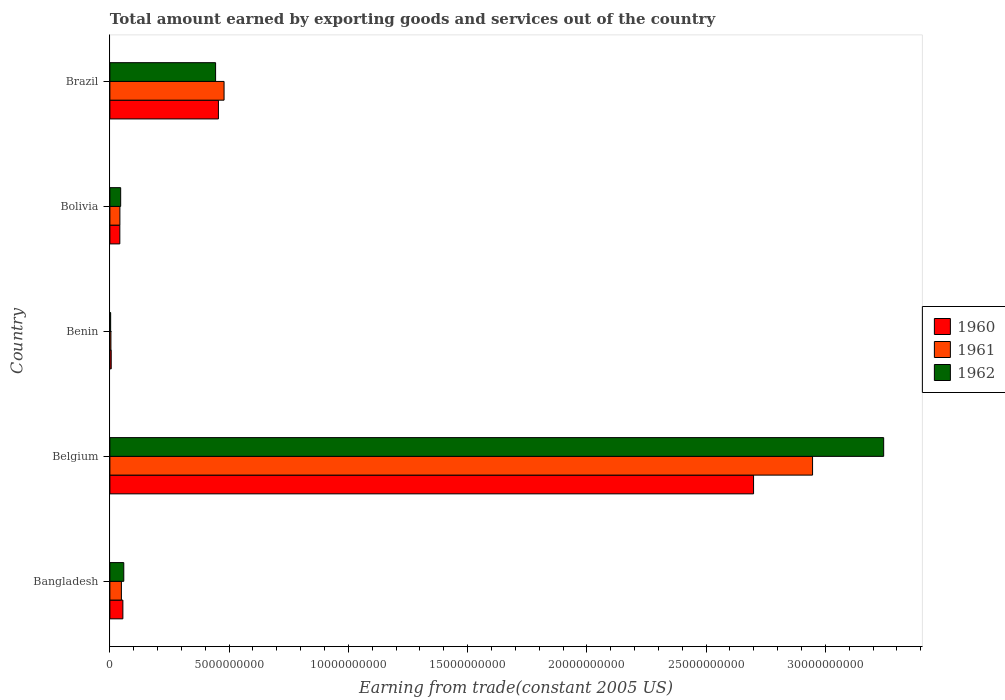How many groups of bars are there?
Provide a succinct answer. 5. Are the number of bars on each tick of the Y-axis equal?
Give a very brief answer. Yes. How many bars are there on the 3rd tick from the top?
Offer a terse response. 3. What is the total amount earned by exporting goods and services in 1962 in Benin?
Provide a short and direct response. 3.19e+07. Across all countries, what is the maximum total amount earned by exporting goods and services in 1960?
Your answer should be compact. 2.70e+1. Across all countries, what is the minimum total amount earned by exporting goods and services in 1960?
Your response must be concise. 5.55e+07. In which country was the total amount earned by exporting goods and services in 1961 minimum?
Your response must be concise. Benin. What is the total total amount earned by exporting goods and services in 1961 in the graph?
Your answer should be very brief. 3.52e+1. What is the difference between the total amount earned by exporting goods and services in 1961 in Bolivia and that in Brazil?
Your response must be concise. -4.37e+09. What is the difference between the total amount earned by exporting goods and services in 1962 in Bolivia and the total amount earned by exporting goods and services in 1960 in Belgium?
Make the answer very short. -2.65e+1. What is the average total amount earned by exporting goods and services in 1962 per country?
Provide a succinct answer. 7.59e+09. What is the difference between the total amount earned by exporting goods and services in 1962 and total amount earned by exporting goods and services in 1960 in Bangladesh?
Make the answer very short. 3.76e+07. In how many countries, is the total amount earned by exporting goods and services in 1962 greater than 17000000000 US$?
Provide a short and direct response. 1. What is the ratio of the total amount earned by exporting goods and services in 1961 in Benin to that in Brazil?
Make the answer very short. 0.01. Is the total amount earned by exporting goods and services in 1961 in Belgium less than that in Brazil?
Your response must be concise. No. Is the difference between the total amount earned by exporting goods and services in 1962 in Bangladesh and Belgium greater than the difference between the total amount earned by exporting goods and services in 1960 in Bangladesh and Belgium?
Provide a succinct answer. No. What is the difference between the highest and the second highest total amount earned by exporting goods and services in 1962?
Offer a very short reply. 2.80e+1. What is the difference between the highest and the lowest total amount earned by exporting goods and services in 1962?
Your answer should be compact. 3.24e+1. What does the 2nd bar from the top in Benin represents?
Keep it short and to the point. 1961. Is it the case that in every country, the sum of the total amount earned by exporting goods and services in 1960 and total amount earned by exporting goods and services in 1961 is greater than the total amount earned by exporting goods and services in 1962?
Keep it short and to the point. Yes. How many bars are there?
Your response must be concise. 15. Are all the bars in the graph horizontal?
Keep it short and to the point. Yes. Are the values on the major ticks of X-axis written in scientific E-notation?
Your answer should be very brief. No. Does the graph contain any zero values?
Ensure brevity in your answer.  No. Where does the legend appear in the graph?
Offer a terse response. Center right. How are the legend labels stacked?
Your answer should be compact. Vertical. What is the title of the graph?
Offer a very short reply. Total amount earned by exporting goods and services out of the country. Does "1960" appear as one of the legend labels in the graph?
Ensure brevity in your answer.  Yes. What is the label or title of the X-axis?
Keep it short and to the point. Earning from trade(constant 2005 US). What is the Earning from trade(constant 2005 US) of 1960 in Bangladesh?
Offer a very short reply. 5.45e+08. What is the Earning from trade(constant 2005 US) in 1961 in Bangladesh?
Offer a terse response. 4.82e+08. What is the Earning from trade(constant 2005 US) of 1962 in Bangladesh?
Your answer should be compact. 5.82e+08. What is the Earning from trade(constant 2005 US) in 1960 in Belgium?
Provide a short and direct response. 2.70e+1. What is the Earning from trade(constant 2005 US) of 1961 in Belgium?
Provide a short and direct response. 2.95e+1. What is the Earning from trade(constant 2005 US) of 1962 in Belgium?
Ensure brevity in your answer.  3.24e+1. What is the Earning from trade(constant 2005 US) of 1960 in Benin?
Your response must be concise. 5.55e+07. What is the Earning from trade(constant 2005 US) in 1961 in Benin?
Give a very brief answer. 4.35e+07. What is the Earning from trade(constant 2005 US) in 1962 in Benin?
Provide a succinct answer. 3.19e+07. What is the Earning from trade(constant 2005 US) of 1960 in Bolivia?
Your answer should be very brief. 4.17e+08. What is the Earning from trade(constant 2005 US) of 1961 in Bolivia?
Keep it short and to the point. 4.19e+08. What is the Earning from trade(constant 2005 US) of 1962 in Bolivia?
Give a very brief answer. 4.52e+08. What is the Earning from trade(constant 2005 US) in 1960 in Brazil?
Keep it short and to the point. 4.55e+09. What is the Earning from trade(constant 2005 US) of 1961 in Brazil?
Your answer should be very brief. 4.79e+09. What is the Earning from trade(constant 2005 US) in 1962 in Brazil?
Your answer should be compact. 4.43e+09. Across all countries, what is the maximum Earning from trade(constant 2005 US) of 1960?
Provide a succinct answer. 2.70e+1. Across all countries, what is the maximum Earning from trade(constant 2005 US) of 1961?
Provide a short and direct response. 2.95e+1. Across all countries, what is the maximum Earning from trade(constant 2005 US) in 1962?
Your response must be concise. 3.24e+1. Across all countries, what is the minimum Earning from trade(constant 2005 US) in 1960?
Offer a very short reply. 5.55e+07. Across all countries, what is the minimum Earning from trade(constant 2005 US) in 1961?
Provide a short and direct response. 4.35e+07. Across all countries, what is the minimum Earning from trade(constant 2005 US) of 1962?
Keep it short and to the point. 3.19e+07. What is the total Earning from trade(constant 2005 US) of 1960 in the graph?
Offer a terse response. 3.26e+1. What is the total Earning from trade(constant 2005 US) in 1961 in the graph?
Your answer should be compact. 3.52e+1. What is the total Earning from trade(constant 2005 US) of 1962 in the graph?
Keep it short and to the point. 3.79e+1. What is the difference between the Earning from trade(constant 2005 US) in 1960 in Bangladesh and that in Belgium?
Your response must be concise. -2.64e+1. What is the difference between the Earning from trade(constant 2005 US) in 1961 in Bangladesh and that in Belgium?
Your answer should be compact. -2.90e+1. What is the difference between the Earning from trade(constant 2005 US) of 1962 in Bangladesh and that in Belgium?
Ensure brevity in your answer.  -3.19e+1. What is the difference between the Earning from trade(constant 2005 US) in 1960 in Bangladesh and that in Benin?
Keep it short and to the point. 4.89e+08. What is the difference between the Earning from trade(constant 2005 US) of 1961 in Bangladesh and that in Benin?
Make the answer very short. 4.38e+08. What is the difference between the Earning from trade(constant 2005 US) in 1962 in Bangladesh and that in Benin?
Make the answer very short. 5.50e+08. What is the difference between the Earning from trade(constant 2005 US) in 1960 in Bangladesh and that in Bolivia?
Your response must be concise. 1.28e+08. What is the difference between the Earning from trade(constant 2005 US) of 1961 in Bangladesh and that in Bolivia?
Give a very brief answer. 6.29e+07. What is the difference between the Earning from trade(constant 2005 US) in 1962 in Bangladesh and that in Bolivia?
Provide a short and direct response. 1.30e+08. What is the difference between the Earning from trade(constant 2005 US) of 1960 in Bangladesh and that in Brazil?
Keep it short and to the point. -4.01e+09. What is the difference between the Earning from trade(constant 2005 US) in 1961 in Bangladesh and that in Brazil?
Give a very brief answer. -4.30e+09. What is the difference between the Earning from trade(constant 2005 US) of 1962 in Bangladesh and that in Brazil?
Your answer should be compact. -3.85e+09. What is the difference between the Earning from trade(constant 2005 US) in 1960 in Belgium and that in Benin?
Offer a terse response. 2.69e+1. What is the difference between the Earning from trade(constant 2005 US) in 1961 in Belgium and that in Benin?
Keep it short and to the point. 2.94e+1. What is the difference between the Earning from trade(constant 2005 US) in 1962 in Belgium and that in Benin?
Your answer should be compact. 3.24e+1. What is the difference between the Earning from trade(constant 2005 US) of 1960 in Belgium and that in Bolivia?
Make the answer very short. 2.66e+1. What is the difference between the Earning from trade(constant 2005 US) in 1961 in Belgium and that in Bolivia?
Provide a short and direct response. 2.90e+1. What is the difference between the Earning from trade(constant 2005 US) of 1962 in Belgium and that in Bolivia?
Give a very brief answer. 3.20e+1. What is the difference between the Earning from trade(constant 2005 US) of 1960 in Belgium and that in Brazil?
Offer a terse response. 2.24e+1. What is the difference between the Earning from trade(constant 2005 US) in 1961 in Belgium and that in Brazil?
Your response must be concise. 2.47e+1. What is the difference between the Earning from trade(constant 2005 US) of 1962 in Belgium and that in Brazil?
Keep it short and to the point. 2.80e+1. What is the difference between the Earning from trade(constant 2005 US) in 1960 in Benin and that in Bolivia?
Your response must be concise. -3.61e+08. What is the difference between the Earning from trade(constant 2005 US) of 1961 in Benin and that in Bolivia?
Offer a very short reply. -3.76e+08. What is the difference between the Earning from trade(constant 2005 US) in 1962 in Benin and that in Bolivia?
Provide a short and direct response. -4.20e+08. What is the difference between the Earning from trade(constant 2005 US) of 1960 in Benin and that in Brazil?
Ensure brevity in your answer.  -4.50e+09. What is the difference between the Earning from trade(constant 2005 US) in 1961 in Benin and that in Brazil?
Make the answer very short. -4.74e+09. What is the difference between the Earning from trade(constant 2005 US) of 1962 in Benin and that in Brazil?
Offer a very short reply. -4.40e+09. What is the difference between the Earning from trade(constant 2005 US) of 1960 in Bolivia and that in Brazil?
Make the answer very short. -4.13e+09. What is the difference between the Earning from trade(constant 2005 US) of 1961 in Bolivia and that in Brazil?
Your response must be concise. -4.37e+09. What is the difference between the Earning from trade(constant 2005 US) in 1962 in Bolivia and that in Brazil?
Your answer should be compact. -3.98e+09. What is the difference between the Earning from trade(constant 2005 US) in 1960 in Bangladesh and the Earning from trade(constant 2005 US) in 1961 in Belgium?
Give a very brief answer. -2.89e+1. What is the difference between the Earning from trade(constant 2005 US) in 1960 in Bangladesh and the Earning from trade(constant 2005 US) in 1962 in Belgium?
Provide a short and direct response. -3.19e+1. What is the difference between the Earning from trade(constant 2005 US) in 1961 in Bangladesh and the Earning from trade(constant 2005 US) in 1962 in Belgium?
Your answer should be compact. -3.20e+1. What is the difference between the Earning from trade(constant 2005 US) in 1960 in Bangladesh and the Earning from trade(constant 2005 US) in 1961 in Benin?
Your answer should be very brief. 5.01e+08. What is the difference between the Earning from trade(constant 2005 US) in 1960 in Bangladesh and the Earning from trade(constant 2005 US) in 1962 in Benin?
Offer a very short reply. 5.13e+08. What is the difference between the Earning from trade(constant 2005 US) of 1961 in Bangladesh and the Earning from trade(constant 2005 US) of 1962 in Benin?
Give a very brief answer. 4.50e+08. What is the difference between the Earning from trade(constant 2005 US) in 1960 in Bangladesh and the Earning from trade(constant 2005 US) in 1961 in Bolivia?
Ensure brevity in your answer.  1.26e+08. What is the difference between the Earning from trade(constant 2005 US) of 1960 in Bangladesh and the Earning from trade(constant 2005 US) of 1962 in Bolivia?
Provide a succinct answer. 9.25e+07. What is the difference between the Earning from trade(constant 2005 US) in 1961 in Bangladesh and the Earning from trade(constant 2005 US) in 1962 in Bolivia?
Ensure brevity in your answer.  2.98e+07. What is the difference between the Earning from trade(constant 2005 US) of 1960 in Bangladesh and the Earning from trade(constant 2005 US) of 1961 in Brazil?
Your answer should be very brief. -4.24e+09. What is the difference between the Earning from trade(constant 2005 US) of 1960 in Bangladesh and the Earning from trade(constant 2005 US) of 1962 in Brazil?
Your answer should be very brief. -3.89e+09. What is the difference between the Earning from trade(constant 2005 US) of 1961 in Bangladesh and the Earning from trade(constant 2005 US) of 1962 in Brazil?
Your answer should be very brief. -3.95e+09. What is the difference between the Earning from trade(constant 2005 US) in 1960 in Belgium and the Earning from trade(constant 2005 US) in 1961 in Benin?
Give a very brief answer. 2.69e+1. What is the difference between the Earning from trade(constant 2005 US) in 1960 in Belgium and the Earning from trade(constant 2005 US) in 1962 in Benin?
Provide a succinct answer. 2.70e+1. What is the difference between the Earning from trade(constant 2005 US) of 1961 in Belgium and the Earning from trade(constant 2005 US) of 1962 in Benin?
Your response must be concise. 2.94e+1. What is the difference between the Earning from trade(constant 2005 US) in 1960 in Belgium and the Earning from trade(constant 2005 US) in 1961 in Bolivia?
Ensure brevity in your answer.  2.66e+1. What is the difference between the Earning from trade(constant 2005 US) in 1960 in Belgium and the Earning from trade(constant 2005 US) in 1962 in Bolivia?
Your answer should be compact. 2.65e+1. What is the difference between the Earning from trade(constant 2005 US) in 1961 in Belgium and the Earning from trade(constant 2005 US) in 1962 in Bolivia?
Keep it short and to the point. 2.90e+1. What is the difference between the Earning from trade(constant 2005 US) of 1960 in Belgium and the Earning from trade(constant 2005 US) of 1961 in Brazil?
Offer a very short reply. 2.22e+1. What is the difference between the Earning from trade(constant 2005 US) of 1960 in Belgium and the Earning from trade(constant 2005 US) of 1962 in Brazil?
Provide a succinct answer. 2.26e+1. What is the difference between the Earning from trade(constant 2005 US) of 1961 in Belgium and the Earning from trade(constant 2005 US) of 1962 in Brazil?
Your answer should be very brief. 2.50e+1. What is the difference between the Earning from trade(constant 2005 US) in 1960 in Benin and the Earning from trade(constant 2005 US) in 1961 in Bolivia?
Give a very brief answer. -3.64e+08. What is the difference between the Earning from trade(constant 2005 US) in 1960 in Benin and the Earning from trade(constant 2005 US) in 1962 in Bolivia?
Keep it short and to the point. -3.97e+08. What is the difference between the Earning from trade(constant 2005 US) in 1961 in Benin and the Earning from trade(constant 2005 US) in 1962 in Bolivia?
Ensure brevity in your answer.  -4.09e+08. What is the difference between the Earning from trade(constant 2005 US) of 1960 in Benin and the Earning from trade(constant 2005 US) of 1961 in Brazil?
Keep it short and to the point. -4.73e+09. What is the difference between the Earning from trade(constant 2005 US) of 1960 in Benin and the Earning from trade(constant 2005 US) of 1962 in Brazil?
Keep it short and to the point. -4.38e+09. What is the difference between the Earning from trade(constant 2005 US) of 1961 in Benin and the Earning from trade(constant 2005 US) of 1962 in Brazil?
Keep it short and to the point. -4.39e+09. What is the difference between the Earning from trade(constant 2005 US) of 1960 in Bolivia and the Earning from trade(constant 2005 US) of 1961 in Brazil?
Give a very brief answer. -4.37e+09. What is the difference between the Earning from trade(constant 2005 US) in 1960 in Bolivia and the Earning from trade(constant 2005 US) in 1962 in Brazil?
Your answer should be compact. -4.02e+09. What is the difference between the Earning from trade(constant 2005 US) of 1961 in Bolivia and the Earning from trade(constant 2005 US) of 1962 in Brazil?
Provide a short and direct response. -4.01e+09. What is the average Earning from trade(constant 2005 US) in 1960 per country?
Offer a terse response. 6.51e+09. What is the average Earning from trade(constant 2005 US) in 1961 per country?
Ensure brevity in your answer.  7.04e+09. What is the average Earning from trade(constant 2005 US) in 1962 per country?
Give a very brief answer. 7.59e+09. What is the difference between the Earning from trade(constant 2005 US) of 1960 and Earning from trade(constant 2005 US) of 1961 in Bangladesh?
Your response must be concise. 6.26e+07. What is the difference between the Earning from trade(constant 2005 US) of 1960 and Earning from trade(constant 2005 US) of 1962 in Bangladesh?
Your answer should be very brief. -3.76e+07. What is the difference between the Earning from trade(constant 2005 US) of 1961 and Earning from trade(constant 2005 US) of 1962 in Bangladesh?
Keep it short and to the point. -1.00e+08. What is the difference between the Earning from trade(constant 2005 US) of 1960 and Earning from trade(constant 2005 US) of 1961 in Belgium?
Your answer should be very brief. -2.47e+09. What is the difference between the Earning from trade(constant 2005 US) of 1960 and Earning from trade(constant 2005 US) of 1962 in Belgium?
Provide a succinct answer. -5.46e+09. What is the difference between the Earning from trade(constant 2005 US) of 1961 and Earning from trade(constant 2005 US) of 1962 in Belgium?
Your response must be concise. -2.98e+09. What is the difference between the Earning from trade(constant 2005 US) in 1960 and Earning from trade(constant 2005 US) in 1961 in Benin?
Ensure brevity in your answer.  1.20e+07. What is the difference between the Earning from trade(constant 2005 US) of 1960 and Earning from trade(constant 2005 US) of 1962 in Benin?
Provide a succinct answer. 2.36e+07. What is the difference between the Earning from trade(constant 2005 US) of 1961 and Earning from trade(constant 2005 US) of 1962 in Benin?
Offer a terse response. 1.15e+07. What is the difference between the Earning from trade(constant 2005 US) of 1960 and Earning from trade(constant 2005 US) of 1961 in Bolivia?
Your answer should be compact. -2.45e+06. What is the difference between the Earning from trade(constant 2005 US) of 1960 and Earning from trade(constant 2005 US) of 1962 in Bolivia?
Your response must be concise. -3.55e+07. What is the difference between the Earning from trade(constant 2005 US) of 1961 and Earning from trade(constant 2005 US) of 1962 in Bolivia?
Give a very brief answer. -3.30e+07. What is the difference between the Earning from trade(constant 2005 US) in 1960 and Earning from trade(constant 2005 US) in 1961 in Brazil?
Your answer should be very brief. -2.36e+08. What is the difference between the Earning from trade(constant 2005 US) of 1960 and Earning from trade(constant 2005 US) of 1962 in Brazil?
Your answer should be very brief. 1.18e+08. What is the difference between the Earning from trade(constant 2005 US) of 1961 and Earning from trade(constant 2005 US) of 1962 in Brazil?
Make the answer very short. 3.55e+08. What is the ratio of the Earning from trade(constant 2005 US) of 1960 in Bangladesh to that in Belgium?
Your answer should be compact. 0.02. What is the ratio of the Earning from trade(constant 2005 US) in 1961 in Bangladesh to that in Belgium?
Offer a very short reply. 0.02. What is the ratio of the Earning from trade(constant 2005 US) in 1962 in Bangladesh to that in Belgium?
Your answer should be compact. 0.02. What is the ratio of the Earning from trade(constant 2005 US) in 1960 in Bangladesh to that in Benin?
Make the answer very short. 9.81. What is the ratio of the Earning from trade(constant 2005 US) of 1961 in Bangladesh to that in Benin?
Offer a very short reply. 11.09. What is the ratio of the Earning from trade(constant 2005 US) in 1962 in Bangladesh to that in Benin?
Your answer should be compact. 18.22. What is the ratio of the Earning from trade(constant 2005 US) of 1960 in Bangladesh to that in Bolivia?
Ensure brevity in your answer.  1.31. What is the ratio of the Earning from trade(constant 2005 US) of 1961 in Bangladesh to that in Bolivia?
Ensure brevity in your answer.  1.15. What is the ratio of the Earning from trade(constant 2005 US) of 1962 in Bangladesh to that in Bolivia?
Offer a terse response. 1.29. What is the ratio of the Earning from trade(constant 2005 US) of 1960 in Bangladesh to that in Brazil?
Offer a very short reply. 0.12. What is the ratio of the Earning from trade(constant 2005 US) in 1961 in Bangladesh to that in Brazil?
Provide a succinct answer. 0.1. What is the ratio of the Earning from trade(constant 2005 US) of 1962 in Bangladesh to that in Brazil?
Make the answer very short. 0.13. What is the ratio of the Earning from trade(constant 2005 US) in 1960 in Belgium to that in Benin?
Keep it short and to the point. 486.17. What is the ratio of the Earning from trade(constant 2005 US) of 1961 in Belgium to that in Benin?
Keep it short and to the point. 677.79. What is the ratio of the Earning from trade(constant 2005 US) of 1962 in Belgium to that in Benin?
Give a very brief answer. 1015.59. What is the ratio of the Earning from trade(constant 2005 US) in 1960 in Belgium to that in Bolivia?
Offer a terse response. 64.78. What is the ratio of the Earning from trade(constant 2005 US) of 1961 in Belgium to that in Bolivia?
Give a very brief answer. 70.31. What is the ratio of the Earning from trade(constant 2005 US) of 1962 in Belgium to that in Bolivia?
Provide a succinct answer. 71.77. What is the ratio of the Earning from trade(constant 2005 US) of 1960 in Belgium to that in Brazil?
Offer a terse response. 5.93. What is the ratio of the Earning from trade(constant 2005 US) in 1961 in Belgium to that in Brazil?
Keep it short and to the point. 6.15. What is the ratio of the Earning from trade(constant 2005 US) of 1962 in Belgium to that in Brazil?
Offer a very short reply. 7.32. What is the ratio of the Earning from trade(constant 2005 US) in 1960 in Benin to that in Bolivia?
Offer a terse response. 0.13. What is the ratio of the Earning from trade(constant 2005 US) of 1961 in Benin to that in Bolivia?
Your answer should be very brief. 0.1. What is the ratio of the Earning from trade(constant 2005 US) in 1962 in Benin to that in Bolivia?
Provide a short and direct response. 0.07. What is the ratio of the Earning from trade(constant 2005 US) in 1960 in Benin to that in Brazil?
Your answer should be compact. 0.01. What is the ratio of the Earning from trade(constant 2005 US) of 1961 in Benin to that in Brazil?
Make the answer very short. 0.01. What is the ratio of the Earning from trade(constant 2005 US) of 1962 in Benin to that in Brazil?
Keep it short and to the point. 0.01. What is the ratio of the Earning from trade(constant 2005 US) of 1960 in Bolivia to that in Brazil?
Make the answer very short. 0.09. What is the ratio of the Earning from trade(constant 2005 US) of 1961 in Bolivia to that in Brazil?
Provide a short and direct response. 0.09. What is the ratio of the Earning from trade(constant 2005 US) of 1962 in Bolivia to that in Brazil?
Keep it short and to the point. 0.1. What is the difference between the highest and the second highest Earning from trade(constant 2005 US) of 1960?
Your answer should be very brief. 2.24e+1. What is the difference between the highest and the second highest Earning from trade(constant 2005 US) in 1961?
Give a very brief answer. 2.47e+1. What is the difference between the highest and the second highest Earning from trade(constant 2005 US) in 1962?
Provide a succinct answer. 2.80e+1. What is the difference between the highest and the lowest Earning from trade(constant 2005 US) of 1960?
Keep it short and to the point. 2.69e+1. What is the difference between the highest and the lowest Earning from trade(constant 2005 US) of 1961?
Your response must be concise. 2.94e+1. What is the difference between the highest and the lowest Earning from trade(constant 2005 US) in 1962?
Offer a terse response. 3.24e+1. 